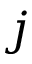<formula> <loc_0><loc_0><loc_500><loc_500>j</formula> 